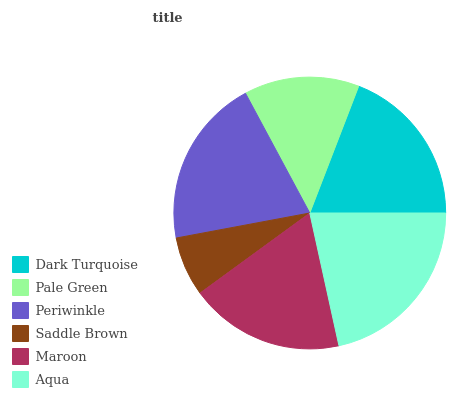Is Saddle Brown the minimum?
Answer yes or no. Yes. Is Aqua the maximum?
Answer yes or no. Yes. Is Pale Green the minimum?
Answer yes or no. No. Is Pale Green the maximum?
Answer yes or no. No. Is Dark Turquoise greater than Pale Green?
Answer yes or no. Yes. Is Pale Green less than Dark Turquoise?
Answer yes or no. Yes. Is Pale Green greater than Dark Turquoise?
Answer yes or no. No. Is Dark Turquoise less than Pale Green?
Answer yes or no. No. Is Dark Turquoise the high median?
Answer yes or no. Yes. Is Maroon the low median?
Answer yes or no. Yes. Is Periwinkle the high median?
Answer yes or no. No. Is Periwinkle the low median?
Answer yes or no. No. 